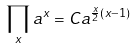<formula> <loc_0><loc_0><loc_500><loc_500>\prod _ { x } a ^ { x } = C a ^ { \frac { x } { 2 } ( x - 1 ) }</formula> 